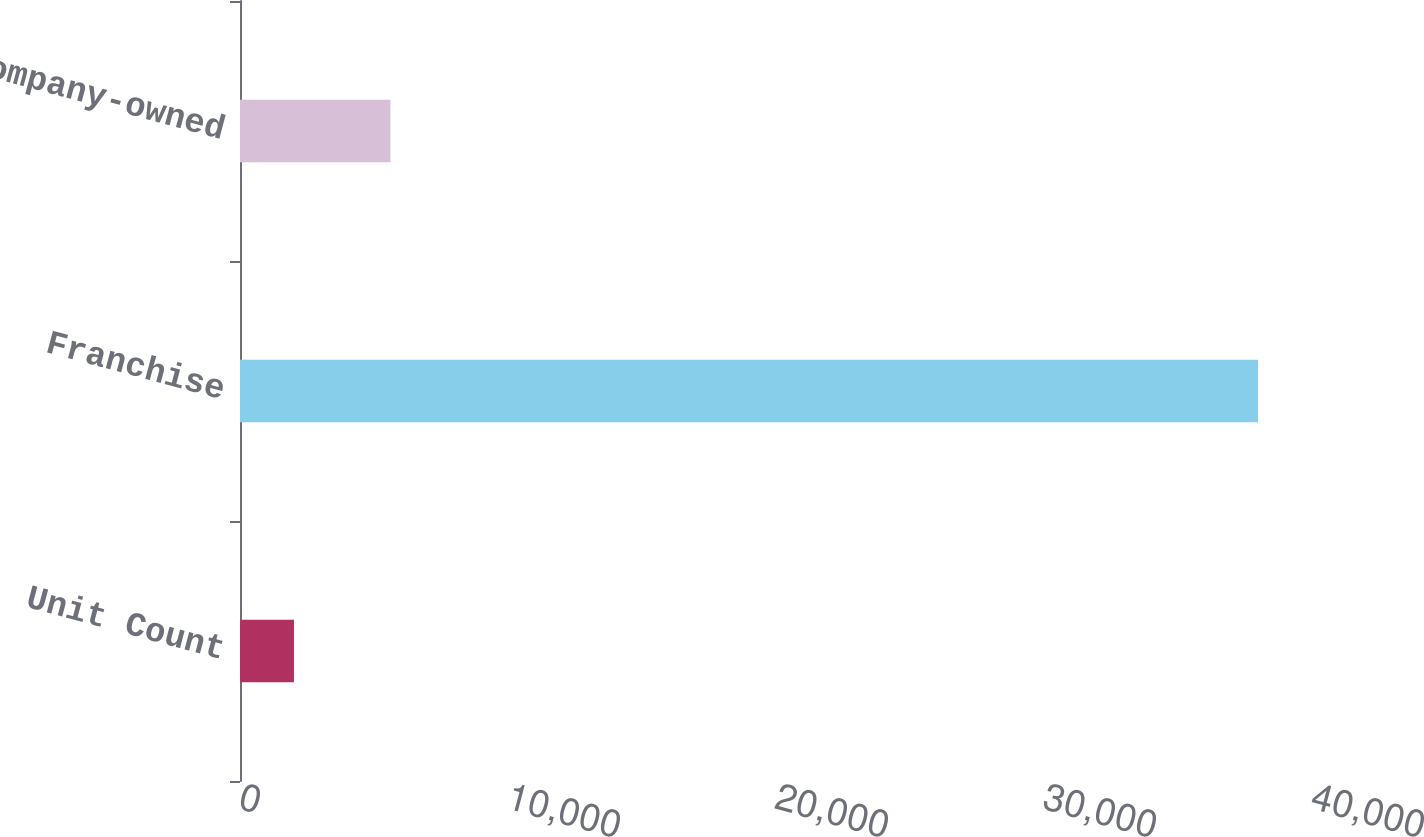Convert chart to OTSL. <chart><loc_0><loc_0><loc_500><loc_500><bar_chart><fcel>Unit Count<fcel>Franchise<fcel>Company-owned<nl><fcel>2014<fcel>37984<fcel>5611<nl></chart> 